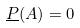Convert formula to latex. <formula><loc_0><loc_0><loc_500><loc_500>\underline { P } ( A ) = 0</formula> 